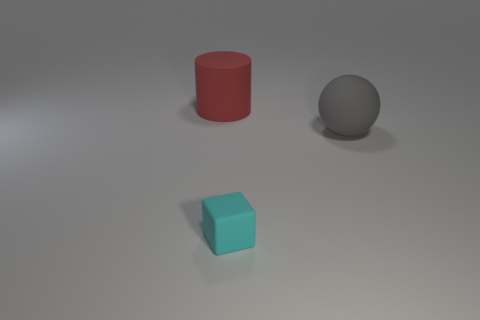Add 2 big things. How many objects exist? 5 Add 3 small yellow cylinders. How many small yellow cylinders exist? 3 Subtract 0 red blocks. How many objects are left? 3 Subtract all cylinders. How many objects are left? 2 Subtract all small cubes. Subtract all cyan cubes. How many objects are left? 1 Add 1 big gray rubber balls. How many big gray rubber balls are left? 2 